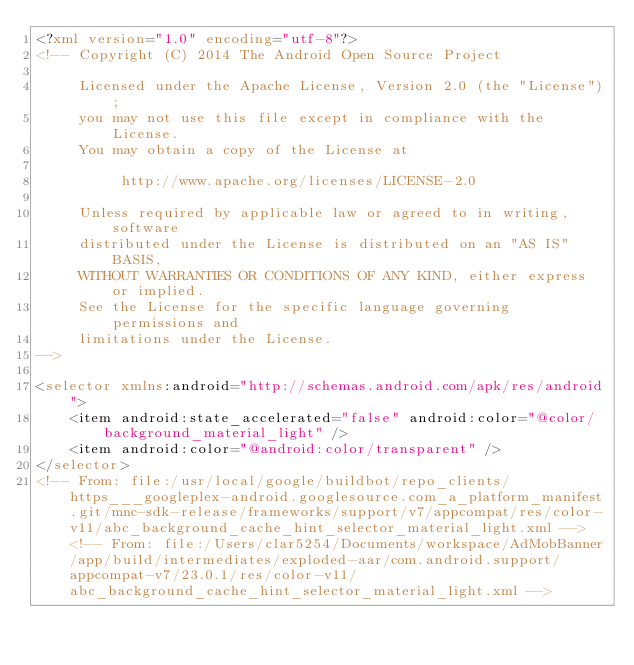Convert code to text. <code><loc_0><loc_0><loc_500><loc_500><_XML_><?xml version="1.0" encoding="utf-8"?>
<!-- Copyright (C) 2014 The Android Open Source Project

     Licensed under the Apache License, Version 2.0 (the "License");
     you may not use this file except in compliance with the License.
     You may obtain a copy of the License at

          http://www.apache.org/licenses/LICENSE-2.0

     Unless required by applicable law or agreed to in writing, software
     distributed under the License is distributed on an "AS IS" BASIS,
     WITHOUT WARRANTIES OR CONDITIONS OF ANY KIND, either express or implied.
     See the License for the specific language governing permissions and
     limitations under the License.
-->

<selector xmlns:android="http://schemas.android.com/apk/res/android">
    <item android:state_accelerated="false" android:color="@color/background_material_light" />
    <item android:color="@android:color/transparent" />
</selector>
<!-- From: file:/usr/local/google/buildbot/repo_clients/https___googleplex-android.googlesource.com_a_platform_manifest.git/mnc-sdk-release/frameworks/support/v7/appcompat/res/color-v11/abc_background_cache_hint_selector_material_light.xml --><!-- From: file:/Users/clar5254/Documents/workspace/AdMobBanner/app/build/intermediates/exploded-aar/com.android.support/appcompat-v7/23.0.1/res/color-v11/abc_background_cache_hint_selector_material_light.xml --></code> 